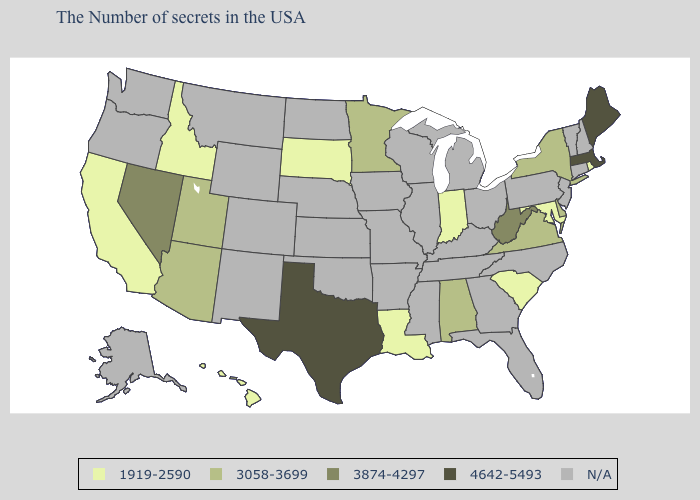Name the states that have a value in the range 1919-2590?
Keep it brief. Rhode Island, Maryland, South Carolina, Indiana, Louisiana, South Dakota, Idaho, California, Hawaii. Among the states that border California , does Nevada have the lowest value?
Short answer required. No. Among the states that border New Mexico , does Texas have the highest value?
Answer briefly. Yes. Does the map have missing data?
Keep it brief. Yes. What is the highest value in the Northeast ?
Short answer required. 4642-5493. Does Idaho have the lowest value in the West?
Answer briefly. Yes. What is the highest value in the Northeast ?
Be succinct. 4642-5493. Name the states that have a value in the range N/A?
Give a very brief answer. New Hampshire, Vermont, Connecticut, New Jersey, Pennsylvania, North Carolina, Ohio, Florida, Georgia, Michigan, Kentucky, Tennessee, Wisconsin, Illinois, Mississippi, Missouri, Arkansas, Iowa, Kansas, Nebraska, Oklahoma, North Dakota, Wyoming, Colorado, New Mexico, Montana, Washington, Oregon, Alaska. Does the map have missing data?
Quick response, please. Yes. Among the states that border Montana , which have the lowest value?
Write a very short answer. South Dakota, Idaho. Name the states that have a value in the range 1919-2590?
Answer briefly. Rhode Island, Maryland, South Carolina, Indiana, Louisiana, South Dakota, Idaho, California, Hawaii. Does Hawaii have the lowest value in the West?
Be succinct. Yes. What is the value of Louisiana?
Write a very short answer. 1919-2590. Which states have the highest value in the USA?
Give a very brief answer. Maine, Massachusetts, Texas. 